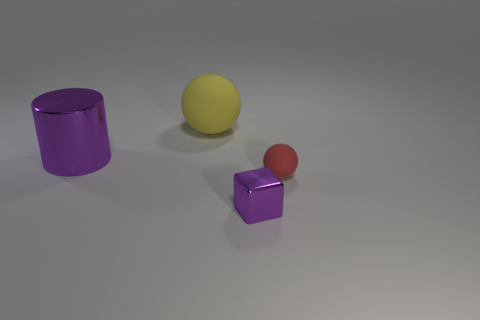Add 4 shiny cylinders. How many objects exist? 8 Subtract all cubes. How many objects are left? 3 Subtract 2 balls. How many balls are left? 0 Add 3 gray rubber spheres. How many gray rubber spheres exist? 3 Subtract 1 purple blocks. How many objects are left? 3 Subtract all yellow balls. Subtract all gray cylinders. How many balls are left? 1 Subtract all big purple cylinders. Subtract all small red rubber objects. How many objects are left? 2 Add 2 metallic cylinders. How many metallic cylinders are left? 3 